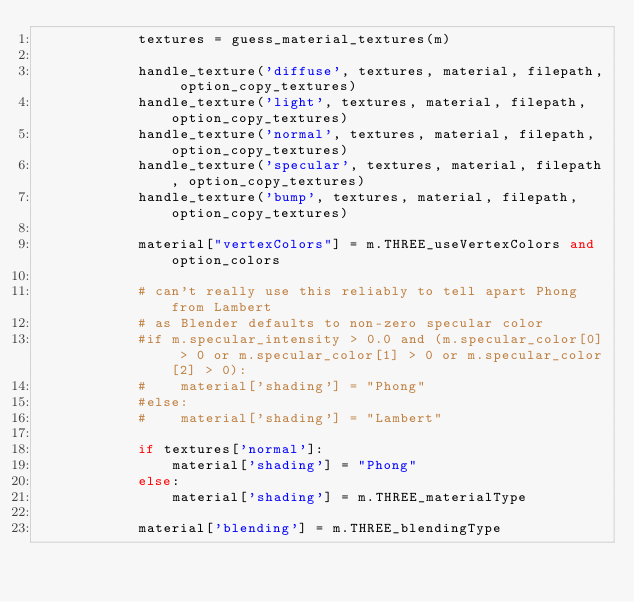<code> <loc_0><loc_0><loc_500><loc_500><_Python_>            textures = guess_material_textures(m)

            handle_texture('diffuse', textures, material, filepath, option_copy_textures)
            handle_texture('light', textures, material, filepath, option_copy_textures)
            handle_texture('normal', textures, material, filepath, option_copy_textures)
            handle_texture('specular', textures, material, filepath, option_copy_textures)
            handle_texture('bump', textures, material, filepath, option_copy_textures)

            material["vertexColors"] = m.THREE_useVertexColors and option_colors

            # can't really use this reliably to tell apart Phong from Lambert
            # as Blender defaults to non-zero specular color
            #if m.specular_intensity > 0.0 and (m.specular_color[0] > 0 or m.specular_color[1] > 0 or m.specular_color[2] > 0):
            #    material['shading'] = "Phong"
            #else:
            #    material['shading'] = "Lambert"

            if textures['normal']:
                material['shading'] = "Phong"
            else:
                material['shading'] = m.THREE_materialType

            material['blending'] = m.THREE_blendingType</code> 